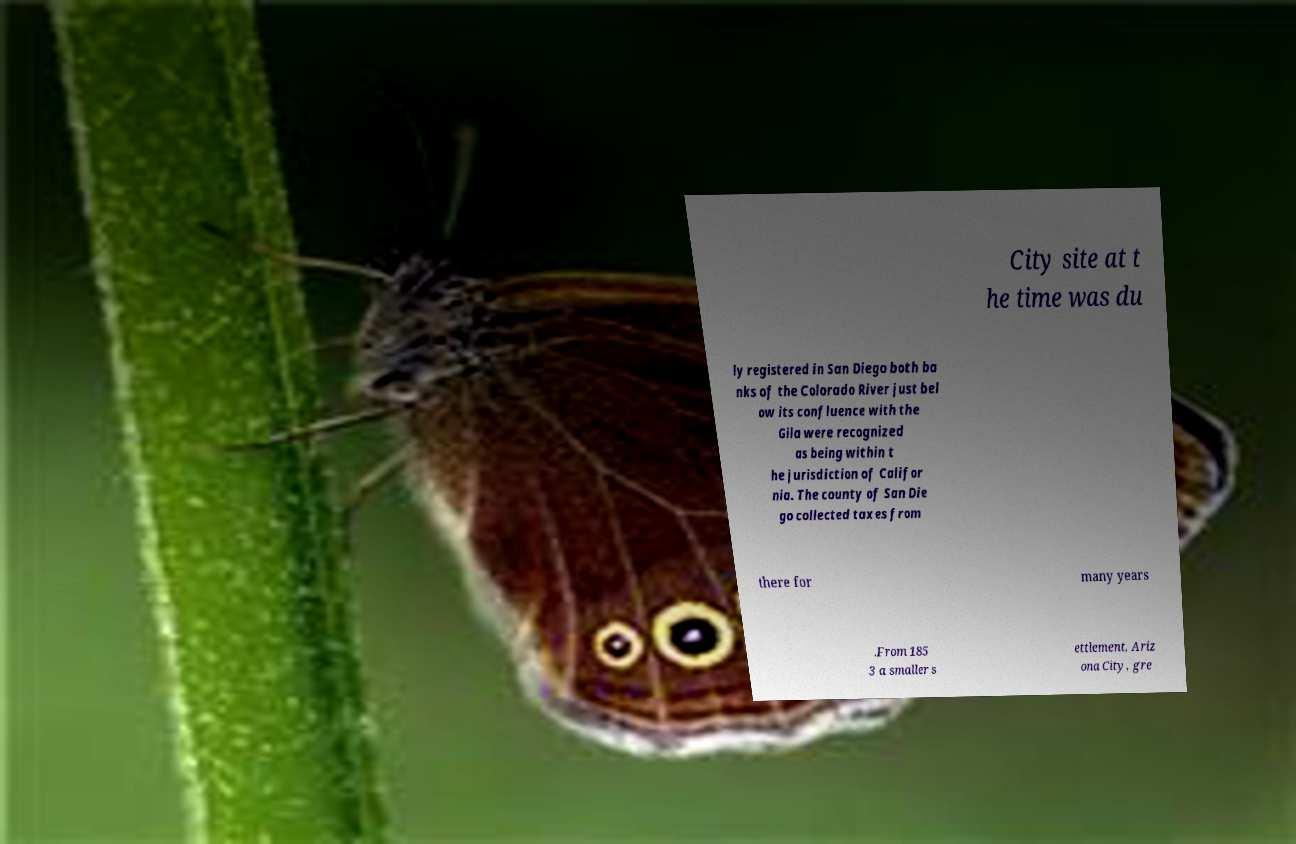What messages or text are displayed in this image? I need them in a readable, typed format. City site at t he time was du ly registered in San Diego both ba nks of the Colorado River just bel ow its confluence with the Gila were recognized as being within t he jurisdiction of Califor nia. The county of San Die go collected taxes from there for many years .From 185 3 a smaller s ettlement, Ariz ona City, gre 